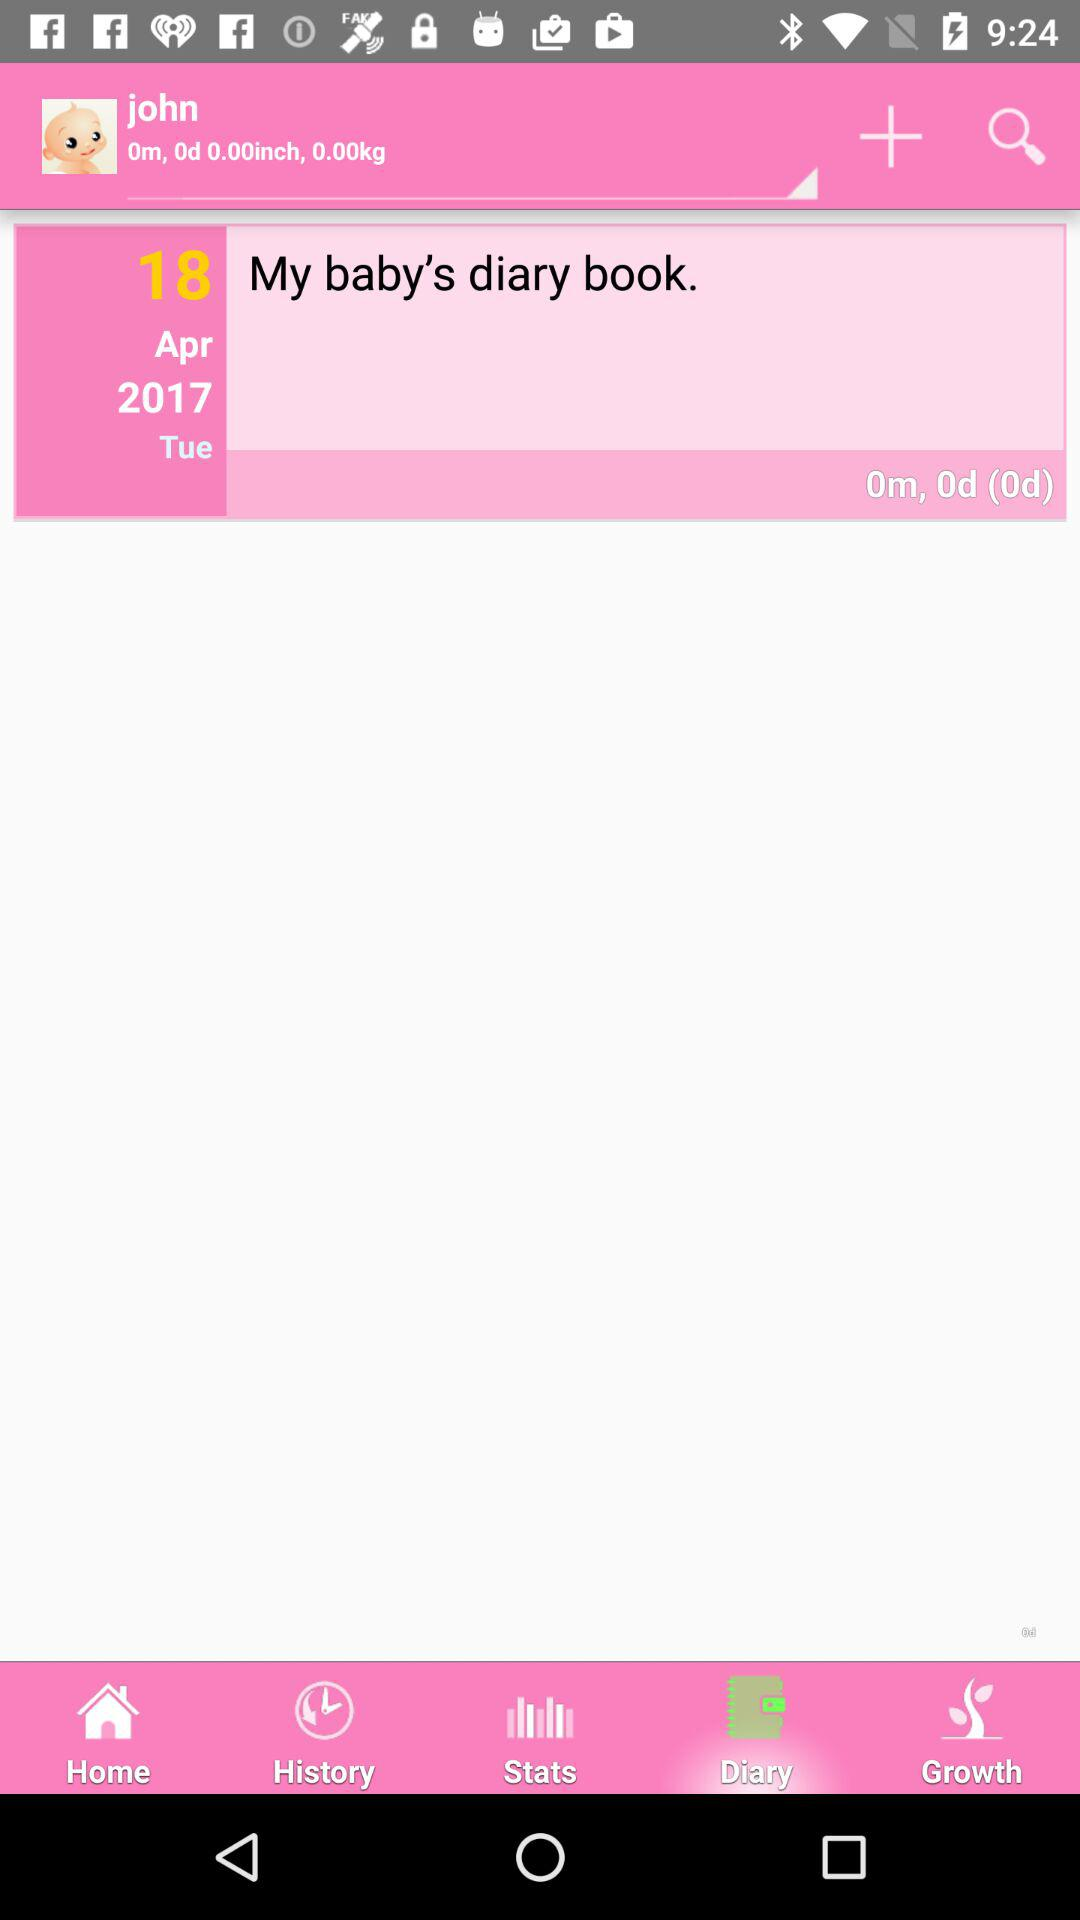What is the height of the baby?
Answer the question using a single word or phrase. 0.00inch 